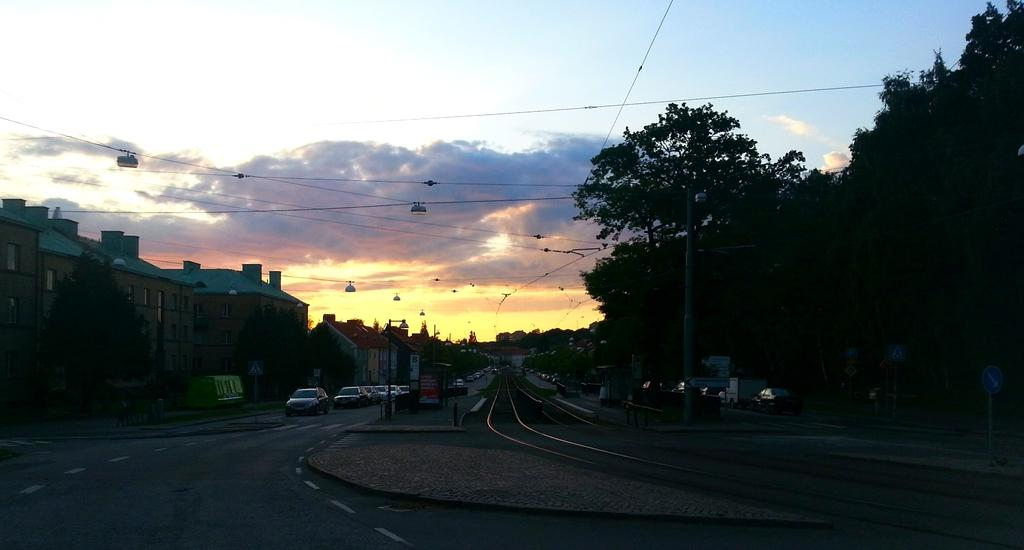What type of structures can be seen on the left side of the image? There are buildings on the left side of the image. What natural elements are present in the image? There are trees in the image. What type of vehicles can be seen in the image? There are cars in the image. How would you describe the setting of the image? The image appears to be a roadside view. What type of riddle can be solved by looking at the image? There is no riddle present in the image, so it cannot be solved by looking at it. Can you tell me how many spades are visible in the image? There are no spades present in the image. 